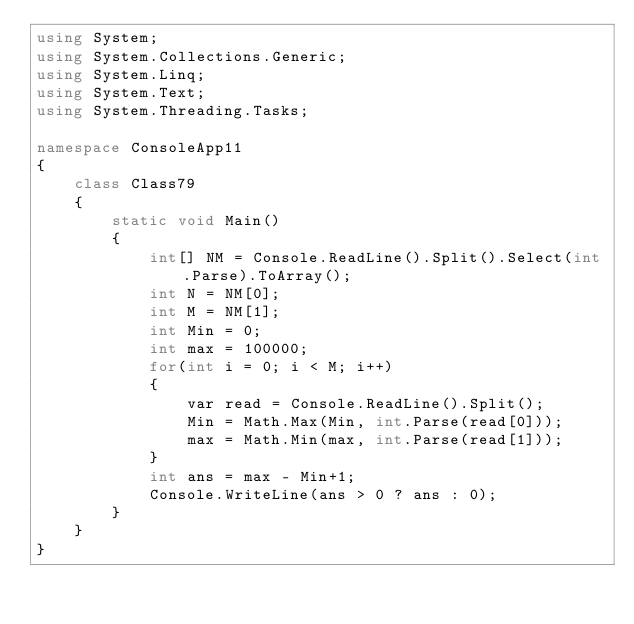Convert code to text. <code><loc_0><loc_0><loc_500><loc_500><_C#_>using System;
using System.Collections.Generic;
using System.Linq;
using System.Text;
using System.Threading.Tasks;

namespace ConsoleApp11
{
    class Class79
    {
        static void Main()
        {
            int[] NM = Console.ReadLine().Split().Select(int.Parse).ToArray();
            int N = NM[0];
            int M = NM[1];
            int Min = 0;
            int max = 100000;
            for(int i = 0; i < M; i++)
            {
                var read = Console.ReadLine().Split();
                Min = Math.Max(Min, int.Parse(read[0]));
                max = Math.Min(max, int.Parse(read[1]));
            }
            int ans = max - Min+1;
            Console.WriteLine(ans > 0 ? ans : 0);
        }
    }
}
</code> 